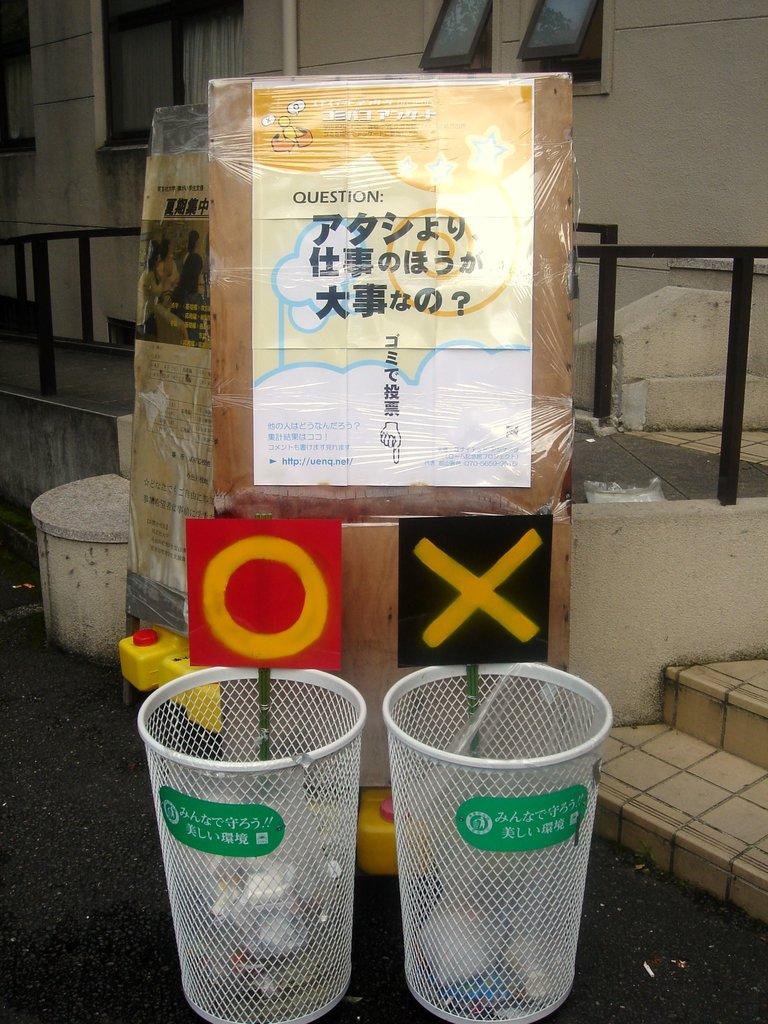What is the letter above the right cup?
Provide a succinct answer. X. What letter is above the left cup?
Your answer should be compact. O. 